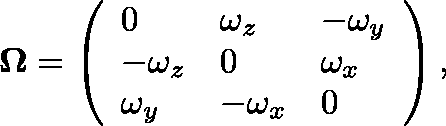<formula> <loc_0><loc_0><loc_500><loc_500>\Omega = \left ( \begin{array} { l l l } { 0 } & { \omega _ { z } } & { - \omega _ { y } } \\ { - \omega _ { z } } & { 0 } & { \omega _ { x } } \\ { \omega _ { y } } & { - \omega _ { x } } & { 0 } \end{array} \right ) ,</formula> 